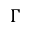Convert formula to latex. <formula><loc_0><loc_0><loc_500><loc_500>\Gamma</formula> 